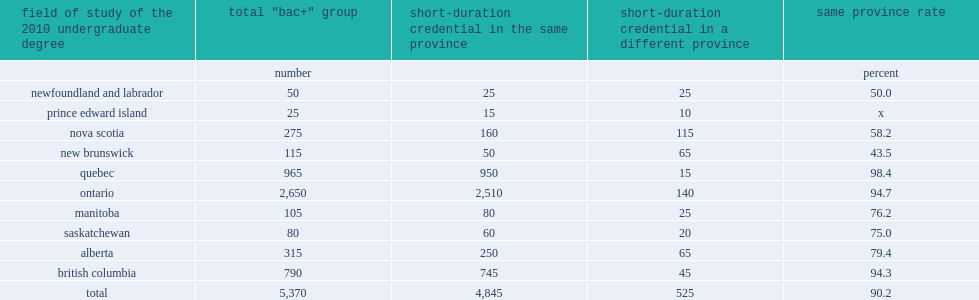Regarding the transition between provinces of study between the first and second educational qualifications, what was the percent of graduates remained in the same province for both of their graduations? 90.2. 